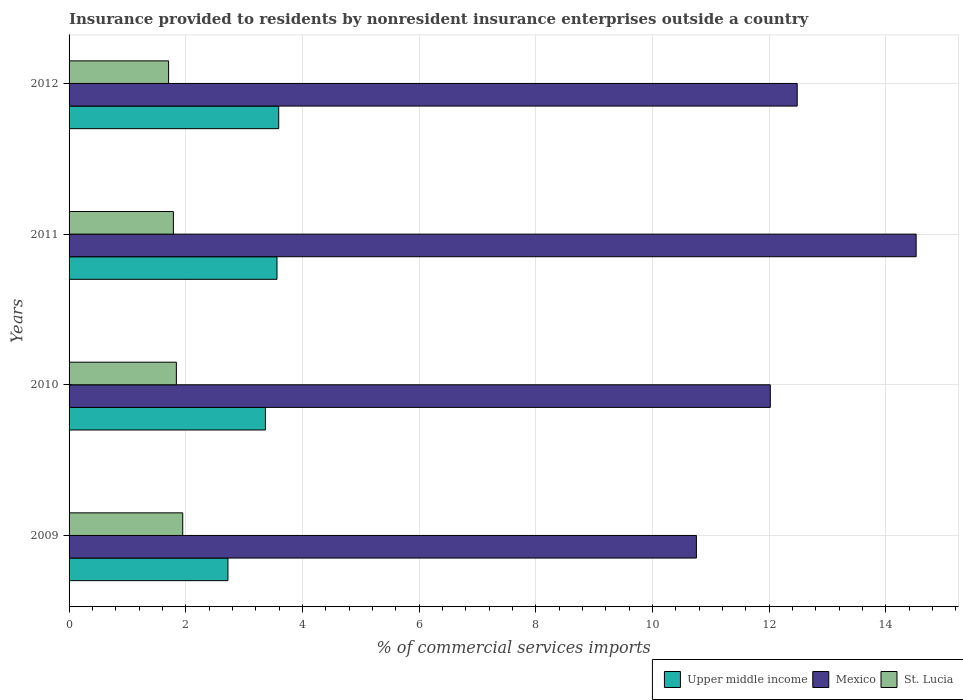How many different coloured bars are there?
Offer a terse response. 3. How many groups of bars are there?
Your answer should be very brief. 4. Are the number of bars per tick equal to the number of legend labels?
Offer a terse response. Yes. How many bars are there on the 2nd tick from the top?
Keep it short and to the point. 3. What is the label of the 2nd group of bars from the top?
Offer a terse response. 2011. What is the Insurance provided to residents in St. Lucia in 2009?
Provide a succinct answer. 1.95. Across all years, what is the maximum Insurance provided to residents in Mexico?
Make the answer very short. 14.52. Across all years, what is the minimum Insurance provided to residents in Mexico?
Your answer should be compact. 10.75. What is the total Insurance provided to residents in Upper middle income in the graph?
Provide a succinct answer. 13.25. What is the difference between the Insurance provided to residents in Upper middle income in 2011 and that in 2012?
Provide a succinct answer. -0.03. What is the difference between the Insurance provided to residents in St. Lucia in 2010 and the Insurance provided to residents in Mexico in 2011?
Your answer should be very brief. -12.68. What is the average Insurance provided to residents in Upper middle income per year?
Give a very brief answer. 3.31. In the year 2012, what is the difference between the Insurance provided to residents in Mexico and Insurance provided to residents in St. Lucia?
Give a very brief answer. 10.77. What is the ratio of the Insurance provided to residents in Upper middle income in 2009 to that in 2012?
Your response must be concise. 0.76. What is the difference between the highest and the second highest Insurance provided to residents in St. Lucia?
Your answer should be very brief. 0.11. What is the difference between the highest and the lowest Insurance provided to residents in St. Lucia?
Your answer should be compact. 0.24. Is the sum of the Insurance provided to residents in St. Lucia in 2009 and 2012 greater than the maximum Insurance provided to residents in Upper middle income across all years?
Give a very brief answer. Yes. What does the 3rd bar from the top in 2012 represents?
Provide a short and direct response. Upper middle income. What does the 1st bar from the bottom in 2011 represents?
Your answer should be compact. Upper middle income. Are all the bars in the graph horizontal?
Give a very brief answer. Yes. How many years are there in the graph?
Your response must be concise. 4. What is the difference between two consecutive major ticks on the X-axis?
Offer a terse response. 2. Does the graph contain any zero values?
Give a very brief answer. No. Does the graph contain grids?
Offer a terse response. Yes. How are the legend labels stacked?
Your response must be concise. Horizontal. What is the title of the graph?
Offer a very short reply. Insurance provided to residents by nonresident insurance enterprises outside a country. Does "Haiti" appear as one of the legend labels in the graph?
Provide a succinct answer. No. What is the label or title of the X-axis?
Keep it short and to the point. % of commercial services imports. What is the % of commercial services imports of Upper middle income in 2009?
Give a very brief answer. 2.72. What is the % of commercial services imports in Mexico in 2009?
Provide a short and direct response. 10.75. What is the % of commercial services imports of St. Lucia in 2009?
Offer a terse response. 1.95. What is the % of commercial services imports in Upper middle income in 2010?
Provide a succinct answer. 3.37. What is the % of commercial services imports of Mexico in 2010?
Offer a very short reply. 12.02. What is the % of commercial services imports of St. Lucia in 2010?
Provide a short and direct response. 1.84. What is the % of commercial services imports in Upper middle income in 2011?
Keep it short and to the point. 3.56. What is the % of commercial services imports of Mexico in 2011?
Your response must be concise. 14.52. What is the % of commercial services imports of St. Lucia in 2011?
Provide a succinct answer. 1.79. What is the % of commercial services imports of Upper middle income in 2012?
Offer a very short reply. 3.59. What is the % of commercial services imports of Mexico in 2012?
Provide a succinct answer. 12.48. What is the % of commercial services imports in St. Lucia in 2012?
Your response must be concise. 1.71. Across all years, what is the maximum % of commercial services imports in Upper middle income?
Your answer should be very brief. 3.59. Across all years, what is the maximum % of commercial services imports of Mexico?
Ensure brevity in your answer.  14.52. Across all years, what is the maximum % of commercial services imports in St. Lucia?
Your answer should be very brief. 1.95. Across all years, what is the minimum % of commercial services imports of Upper middle income?
Offer a terse response. 2.72. Across all years, what is the minimum % of commercial services imports of Mexico?
Your response must be concise. 10.75. Across all years, what is the minimum % of commercial services imports in St. Lucia?
Provide a succinct answer. 1.71. What is the total % of commercial services imports in Upper middle income in the graph?
Ensure brevity in your answer.  13.25. What is the total % of commercial services imports of Mexico in the graph?
Keep it short and to the point. 49.77. What is the total % of commercial services imports in St. Lucia in the graph?
Offer a very short reply. 7.28. What is the difference between the % of commercial services imports in Upper middle income in 2009 and that in 2010?
Your answer should be very brief. -0.64. What is the difference between the % of commercial services imports in Mexico in 2009 and that in 2010?
Offer a terse response. -1.27. What is the difference between the % of commercial services imports in St. Lucia in 2009 and that in 2010?
Make the answer very short. 0.11. What is the difference between the % of commercial services imports in Upper middle income in 2009 and that in 2011?
Your answer should be compact. -0.84. What is the difference between the % of commercial services imports in Mexico in 2009 and that in 2011?
Your answer should be very brief. -3.77. What is the difference between the % of commercial services imports in St. Lucia in 2009 and that in 2011?
Keep it short and to the point. 0.16. What is the difference between the % of commercial services imports of Upper middle income in 2009 and that in 2012?
Your answer should be very brief. -0.87. What is the difference between the % of commercial services imports of Mexico in 2009 and that in 2012?
Ensure brevity in your answer.  -1.73. What is the difference between the % of commercial services imports of St. Lucia in 2009 and that in 2012?
Provide a short and direct response. 0.24. What is the difference between the % of commercial services imports of Upper middle income in 2010 and that in 2011?
Offer a very short reply. -0.2. What is the difference between the % of commercial services imports in Mexico in 2010 and that in 2011?
Offer a terse response. -2.5. What is the difference between the % of commercial services imports of St. Lucia in 2010 and that in 2011?
Offer a very short reply. 0.05. What is the difference between the % of commercial services imports in Upper middle income in 2010 and that in 2012?
Give a very brief answer. -0.23. What is the difference between the % of commercial services imports in Mexico in 2010 and that in 2012?
Give a very brief answer. -0.46. What is the difference between the % of commercial services imports of St. Lucia in 2010 and that in 2012?
Provide a succinct answer. 0.13. What is the difference between the % of commercial services imports of Upper middle income in 2011 and that in 2012?
Your response must be concise. -0.03. What is the difference between the % of commercial services imports in Mexico in 2011 and that in 2012?
Offer a terse response. 2.04. What is the difference between the % of commercial services imports of St. Lucia in 2011 and that in 2012?
Give a very brief answer. 0.08. What is the difference between the % of commercial services imports in Upper middle income in 2009 and the % of commercial services imports in Mexico in 2010?
Provide a short and direct response. -9.3. What is the difference between the % of commercial services imports of Upper middle income in 2009 and the % of commercial services imports of St. Lucia in 2010?
Offer a terse response. 0.88. What is the difference between the % of commercial services imports in Mexico in 2009 and the % of commercial services imports in St. Lucia in 2010?
Ensure brevity in your answer.  8.91. What is the difference between the % of commercial services imports in Upper middle income in 2009 and the % of commercial services imports in Mexico in 2011?
Offer a very short reply. -11.79. What is the difference between the % of commercial services imports of Upper middle income in 2009 and the % of commercial services imports of St. Lucia in 2011?
Make the answer very short. 0.94. What is the difference between the % of commercial services imports of Mexico in 2009 and the % of commercial services imports of St. Lucia in 2011?
Your answer should be very brief. 8.96. What is the difference between the % of commercial services imports in Upper middle income in 2009 and the % of commercial services imports in Mexico in 2012?
Your answer should be very brief. -9.76. What is the difference between the % of commercial services imports in Upper middle income in 2009 and the % of commercial services imports in St. Lucia in 2012?
Give a very brief answer. 1.02. What is the difference between the % of commercial services imports in Mexico in 2009 and the % of commercial services imports in St. Lucia in 2012?
Provide a short and direct response. 9.05. What is the difference between the % of commercial services imports of Upper middle income in 2010 and the % of commercial services imports of Mexico in 2011?
Offer a very short reply. -11.15. What is the difference between the % of commercial services imports of Upper middle income in 2010 and the % of commercial services imports of St. Lucia in 2011?
Offer a terse response. 1.58. What is the difference between the % of commercial services imports of Mexico in 2010 and the % of commercial services imports of St. Lucia in 2011?
Give a very brief answer. 10.23. What is the difference between the % of commercial services imports of Upper middle income in 2010 and the % of commercial services imports of Mexico in 2012?
Ensure brevity in your answer.  -9.11. What is the difference between the % of commercial services imports in Upper middle income in 2010 and the % of commercial services imports in St. Lucia in 2012?
Give a very brief answer. 1.66. What is the difference between the % of commercial services imports in Mexico in 2010 and the % of commercial services imports in St. Lucia in 2012?
Your response must be concise. 10.31. What is the difference between the % of commercial services imports of Upper middle income in 2011 and the % of commercial services imports of Mexico in 2012?
Make the answer very short. -8.92. What is the difference between the % of commercial services imports in Upper middle income in 2011 and the % of commercial services imports in St. Lucia in 2012?
Provide a succinct answer. 1.86. What is the difference between the % of commercial services imports of Mexico in 2011 and the % of commercial services imports of St. Lucia in 2012?
Offer a very short reply. 12.81. What is the average % of commercial services imports of Upper middle income per year?
Ensure brevity in your answer.  3.31. What is the average % of commercial services imports of Mexico per year?
Your answer should be very brief. 12.44. What is the average % of commercial services imports of St. Lucia per year?
Offer a very short reply. 1.82. In the year 2009, what is the difference between the % of commercial services imports of Upper middle income and % of commercial services imports of Mexico?
Keep it short and to the point. -8.03. In the year 2009, what is the difference between the % of commercial services imports of Upper middle income and % of commercial services imports of St. Lucia?
Give a very brief answer. 0.78. In the year 2009, what is the difference between the % of commercial services imports in Mexico and % of commercial services imports in St. Lucia?
Offer a very short reply. 8.8. In the year 2010, what is the difference between the % of commercial services imports of Upper middle income and % of commercial services imports of Mexico?
Provide a succinct answer. -8.65. In the year 2010, what is the difference between the % of commercial services imports of Upper middle income and % of commercial services imports of St. Lucia?
Your answer should be compact. 1.53. In the year 2010, what is the difference between the % of commercial services imports of Mexico and % of commercial services imports of St. Lucia?
Make the answer very short. 10.18. In the year 2011, what is the difference between the % of commercial services imports of Upper middle income and % of commercial services imports of Mexico?
Your answer should be compact. -10.95. In the year 2011, what is the difference between the % of commercial services imports in Upper middle income and % of commercial services imports in St. Lucia?
Make the answer very short. 1.78. In the year 2011, what is the difference between the % of commercial services imports of Mexico and % of commercial services imports of St. Lucia?
Your response must be concise. 12.73. In the year 2012, what is the difference between the % of commercial services imports of Upper middle income and % of commercial services imports of Mexico?
Offer a terse response. -8.89. In the year 2012, what is the difference between the % of commercial services imports of Upper middle income and % of commercial services imports of St. Lucia?
Your answer should be very brief. 1.89. In the year 2012, what is the difference between the % of commercial services imports of Mexico and % of commercial services imports of St. Lucia?
Provide a succinct answer. 10.77. What is the ratio of the % of commercial services imports of Upper middle income in 2009 to that in 2010?
Your answer should be compact. 0.81. What is the ratio of the % of commercial services imports in Mexico in 2009 to that in 2010?
Provide a short and direct response. 0.89. What is the ratio of the % of commercial services imports in St. Lucia in 2009 to that in 2010?
Provide a short and direct response. 1.06. What is the ratio of the % of commercial services imports in Upper middle income in 2009 to that in 2011?
Ensure brevity in your answer.  0.76. What is the ratio of the % of commercial services imports in Mexico in 2009 to that in 2011?
Make the answer very short. 0.74. What is the ratio of the % of commercial services imports of St. Lucia in 2009 to that in 2011?
Your response must be concise. 1.09. What is the ratio of the % of commercial services imports of Upper middle income in 2009 to that in 2012?
Provide a short and direct response. 0.76. What is the ratio of the % of commercial services imports in Mexico in 2009 to that in 2012?
Provide a succinct answer. 0.86. What is the ratio of the % of commercial services imports of St. Lucia in 2009 to that in 2012?
Provide a short and direct response. 1.14. What is the ratio of the % of commercial services imports of Upper middle income in 2010 to that in 2011?
Offer a terse response. 0.94. What is the ratio of the % of commercial services imports in Mexico in 2010 to that in 2011?
Make the answer very short. 0.83. What is the ratio of the % of commercial services imports of St. Lucia in 2010 to that in 2011?
Your answer should be compact. 1.03. What is the ratio of the % of commercial services imports of Upper middle income in 2010 to that in 2012?
Your response must be concise. 0.94. What is the ratio of the % of commercial services imports of Mexico in 2010 to that in 2012?
Your answer should be compact. 0.96. What is the ratio of the % of commercial services imports in St. Lucia in 2010 to that in 2012?
Provide a succinct answer. 1.08. What is the ratio of the % of commercial services imports in Upper middle income in 2011 to that in 2012?
Keep it short and to the point. 0.99. What is the ratio of the % of commercial services imports of Mexico in 2011 to that in 2012?
Ensure brevity in your answer.  1.16. What is the ratio of the % of commercial services imports in St. Lucia in 2011 to that in 2012?
Make the answer very short. 1.05. What is the difference between the highest and the second highest % of commercial services imports of Upper middle income?
Ensure brevity in your answer.  0.03. What is the difference between the highest and the second highest % of commercial services imports in Mexico?
Make the answer very short. 2.04. What is the difference between the highest and the second highest % of commercial services imports of St. Lucia?
Provide a short and direct response. 0.11. What is the difference between the highest and the lowest % of commercial services imports in Upper middle income?
Offer a terse response. 0.87. What is the difference between the highest and the lowest % of commercial services imports of Mexico?
Offer a very short reply. 3.77. What is the difference between the highest and the lowest % of commercial services imports of St. Lucia?
Keep it short and to the point. 0.24. 